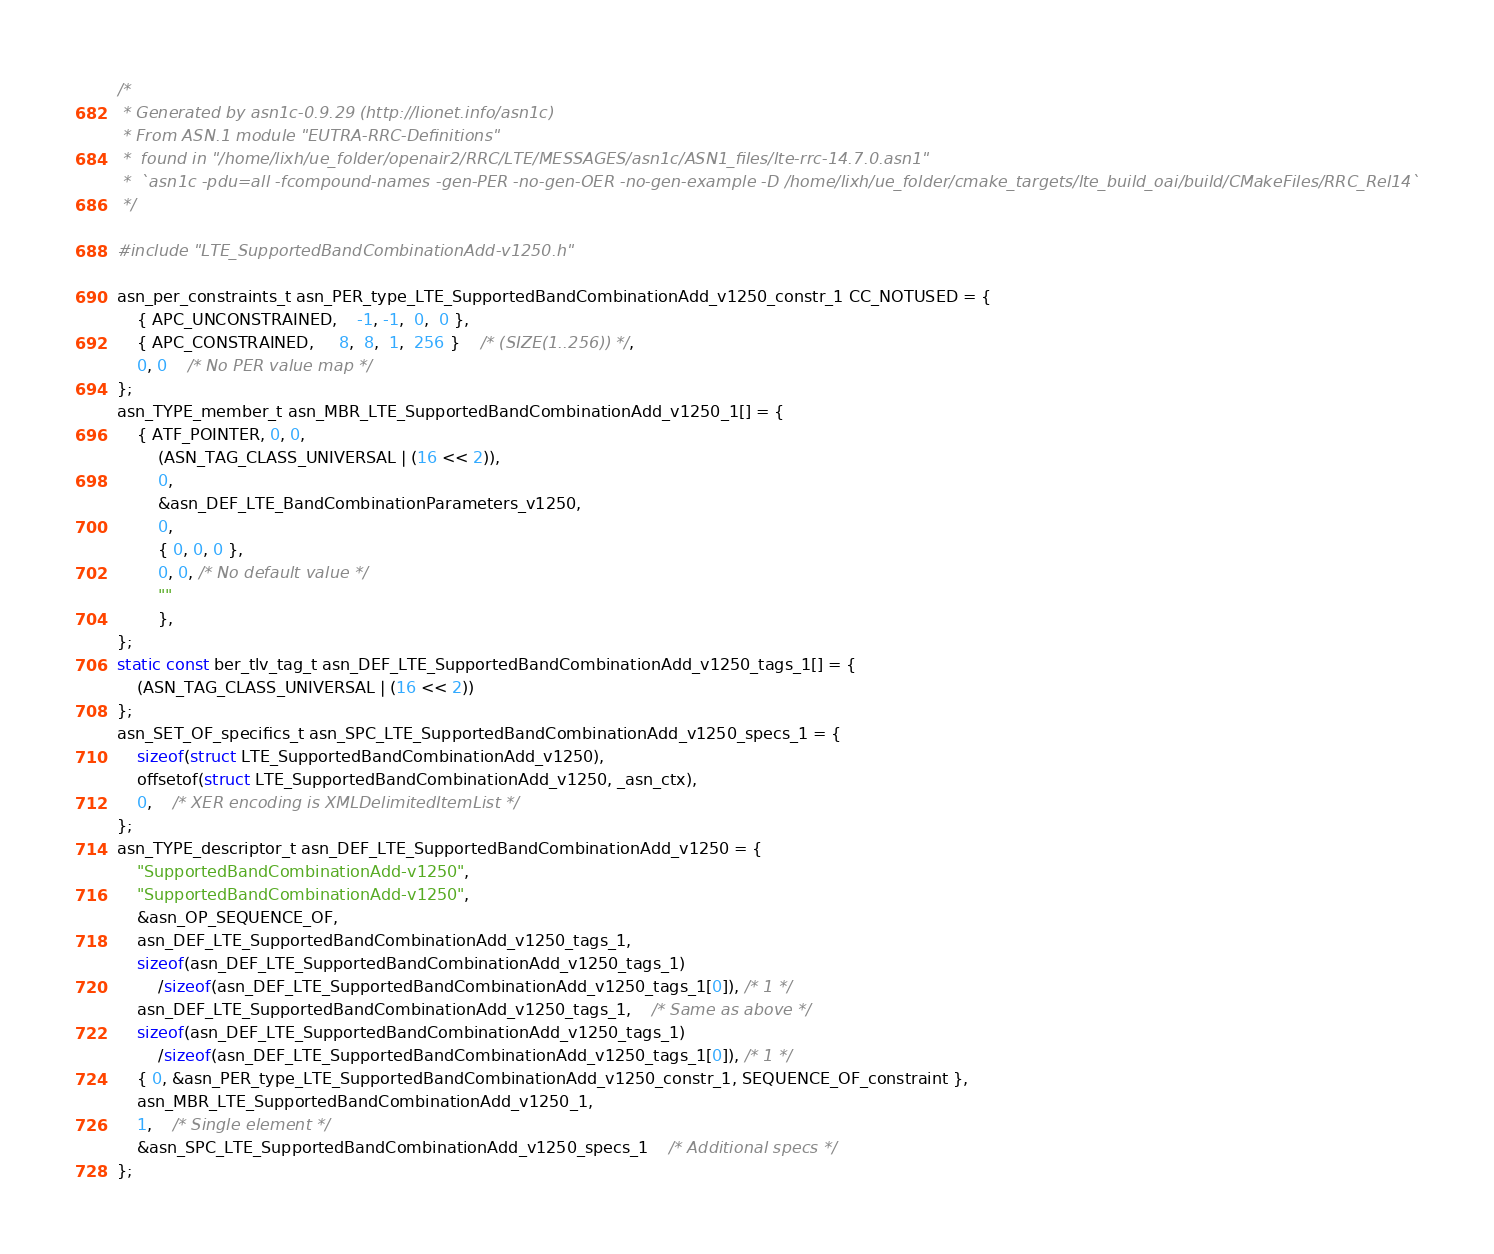<code> <loc_0><loc_0><loc_500><loc_500><_C_>/*
 * Generated by asn1c-0.9.29 (http://lionet.info/asn1c)
 * From ASN.1 module "EUTRA-RRC-Definitions"
 * 	found in "/home/lixh/ue_folder/openair2/RRC/LTE/MESSAGES/asn1c/ASN1_files/lte-rrc-14.7.0.asn1"
 * 	`asn1c -pdu=all -fcompound-names -gen-PER -no-gen-OER -no-gen-example -D /home/lixh/ue_folder/cmake_targets/lte_build_oai/build/CMakeFiles/RRC_Rel14`
 */

#include "LTE_SupportedBandCombinationAdd-v1250.h"

asn_per_constraints_t asn_PER_type_LTE_SupportedBandCombinationAdd_v1250_constr_1 CC_NOTUSED = {
	{ APC_UNCONSTRAINED,	-1, -1,  0,  0 },
	{ APC_CONSTRAINED,	 8,  8,  1,  256 }	/* (SIZE(1..256)) */,
	0, 0	/* No PER value map */
};
asn_TYPE_member_t asn_MBR_LTE_SupportedBandCombinationAdd_v1250_1[] = {
	{ ATF_POINTER, 0, 0,
		(ASN_TAG_CLASS_UNIVERSAL | (16 << 2)),
		0,
		&asn_DEF_LTE_BandCombinationParameters_v1250,
		0,
		{ 0, 0, 0 },
		0, 0, /* No default value */
		""
		},
};
static const ber_tlv_tag_t asn_DEF_LTE_SupportedBandCombinationAdd_v1250_tags_1[] = {
	(ASN_TAG_CLASS_UNIVERSAL | (16 << 2))
};
asn_SET_OF_specifics_t asn_SPC_LTE_SupportedBandCombinationAdd_v1250_specs_1 = {
	sizeof(struct LTE_SupportedBandCombinationAdd_v1250),
	offsetof(struct LTE_SupportedBandCombinationAdd_v1250, _asn_ctx),
	0,	/* XER encoding is XMLDelimitedItemList */
};
asn_TYPE_descriptor_t asn_DEF_LTE_SupportedBandCombinationAdd_v1250 = {
	"SupportedBandCombinationAdd-v1250",
	"SupportedBandCombinationAdd-v1250",
	&asn_OP_SEQUENCE_OF,
	asn_DEF_LTE_SupportedBandCombinationAdd_v1250_tags_1,
	sizeof(asn_DEF_LTE_SupportedBandCombinationAdd_v1250_tags_1)
		/sizeof(asn_DEF_LTE_SupportedBandCombinationAdd_v1250_tags_1[0]), /* 1 */
	asn_DEF_LTE_SupportedBandCombinationAdd_v1250_tags_1,	/* Same as above */
	sizeof(asn_DEF_LTE_SupportedBandCombinationAdd_v1250_tags_1)
		/sizeof(asn_DEF_LTE_SupportedBandCombinationAdd_v1250_tags_1[0]), /* 1 */
	{ 0, &asn_PER_type_LTE_SupportedBandCombinationAdd_v1250_constr_1, SEQUENCE_OF_constraint },
	asn_MBR_LTE_SupportedBandCombinationAdd_v1250_1,
	1,	/* Single element */
	&asn_SPC_LTE_SupportedBandCombinationAdd_v1250_specs_1	/* Additional specs */
};

</code> 